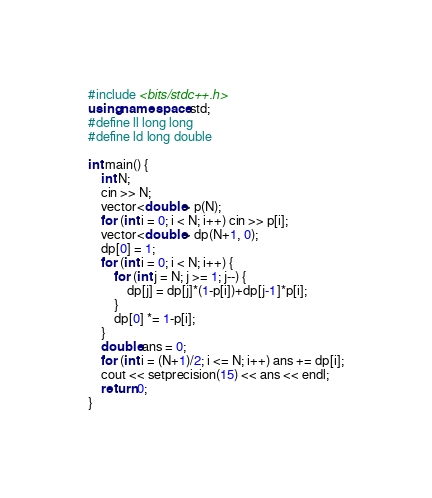<code> <loc_0><loc_0><loc_500><loc_500><_C++_>#include <bits/stdc++.h>
using namespace std;
#define ll long long
#define ld long double

int main() {
    int N;
    cin >> N;
    vector<double> p(N);
    for (int i = 0; i < N; i++) cin >> p[i];
    vector<double> dp(N+1, 0);
    dp[0] = 1;
    for (int i = 0; i < N; i++) {
        for (int j = N; j >= 1; j--) {
            dp[j] = dp[j]*(1-p[i])+dp[j-1]*p[i];
        }
        dp[0] *= 1-p[i];
    }
    double ans = 0;
    for (int i = (N+1)/2; i <= N; i++) ans += dp[i];
    cout << setprecision(15) << ans << endl;
    return 0;
}</code> 